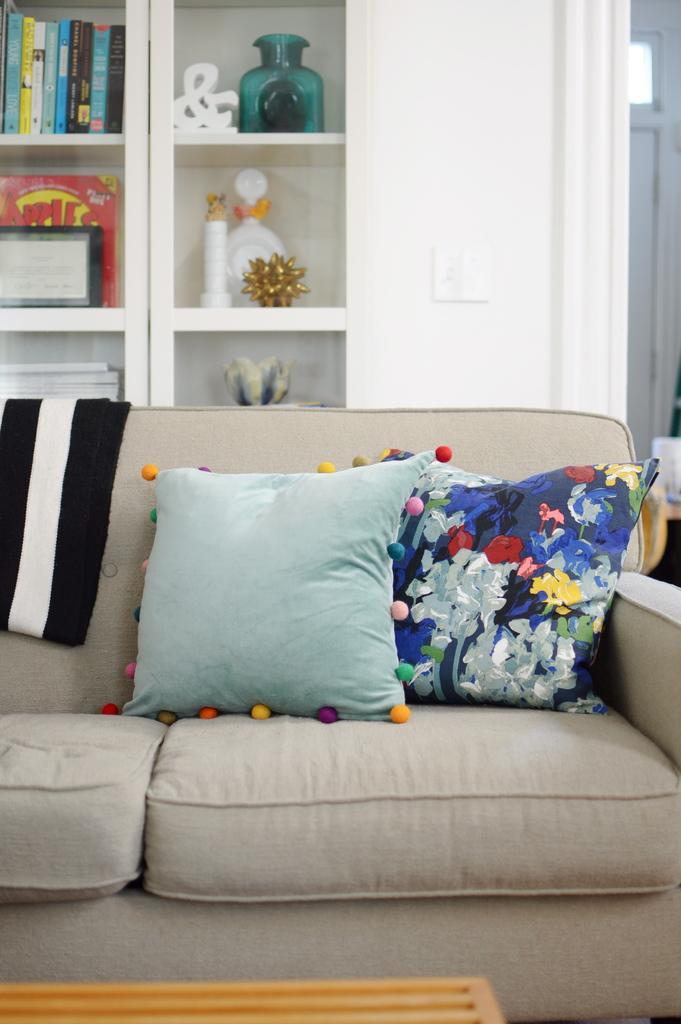Can you describe this image briefly? In this image we can see sofa with pillows. In the background we can see books and some things in the cupboard. 